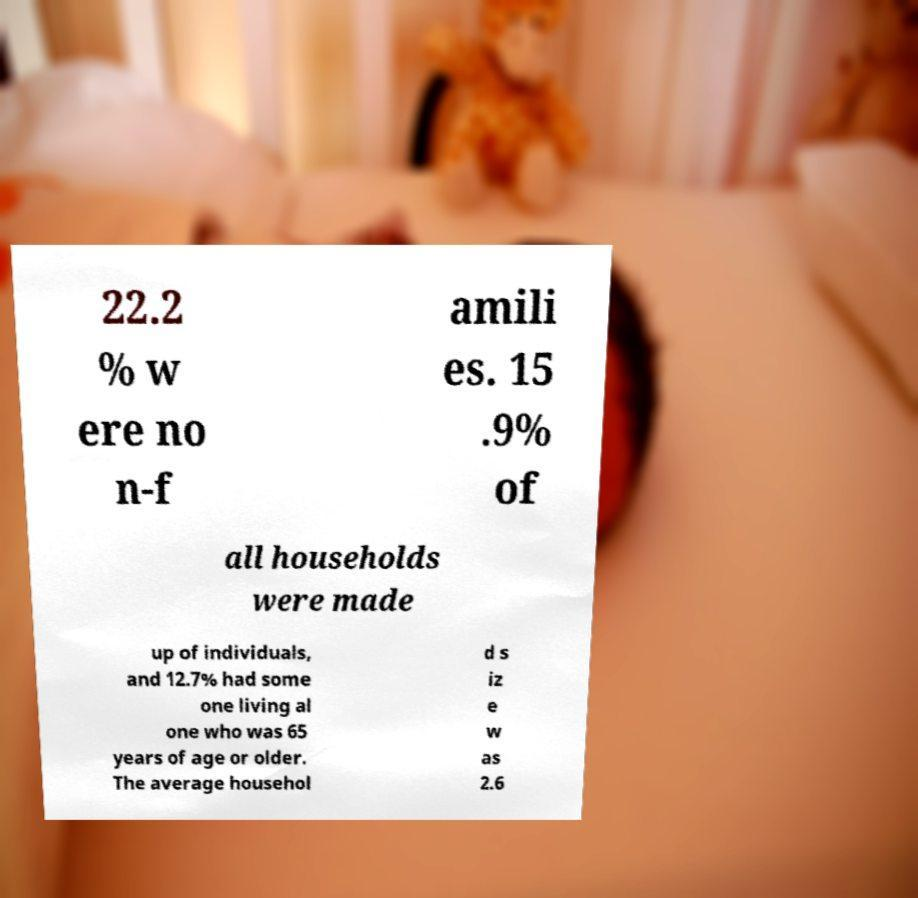What messages or text are displayed in this image? I need them in a readable, typed format. 22.2 % w ere no n-f amili es. 15 .9% of all households were made up of individuals, and 12.7% had some one living al one who was 65 years of age or older. The average househol d s iz e w as 2.6 